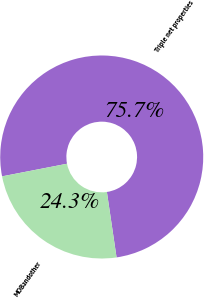Convert chart to OTSL. <chart><loc_0><loc_0><loc_500><loc_500><pie_chart><fcel>Triple net properties<fcel>MOBandother<nl><fcel>75.72%<fcel>24.28%<nl></chart> 